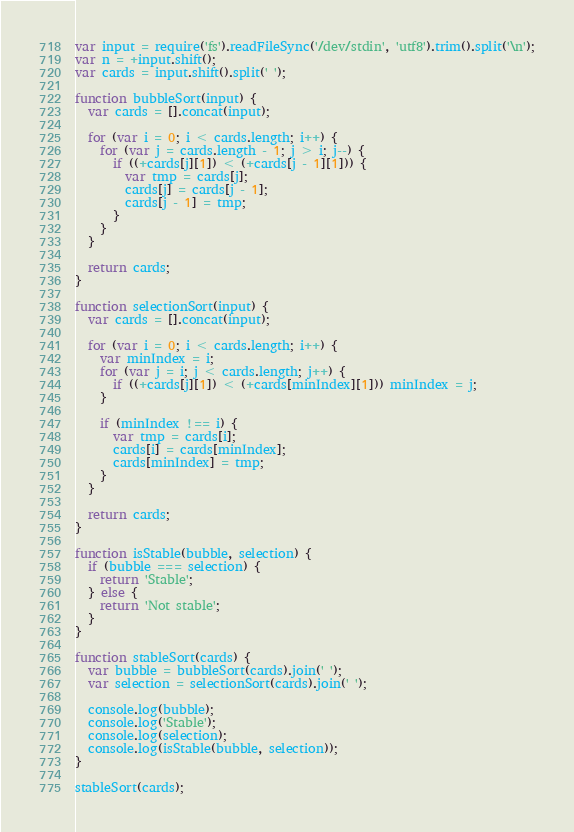<code> <loc_0><loc_0><loc_500><loc_500><_JavaScript_>var input = require('fs').readFileSync('/dev/stdin', 'utf8').trim().split('\n');
var n = +input.shift();
var cards = input.shift().split(' ');

function bubbleSort(input) {
  var cards = [].concat(input);

  for (var i = 0; i < cards.length; i++) {
    for (var j = cards.length - 1; j > i; j--) {
      if ((+cards[j][1]) < (+cards[j - 1][1])) {
        var tmp = cards[j];
        cards[j] = cards[j - 1];
        cards[j - 1] = tmp;
      }
    }
  }

  return cards;
}

function selectionSort(input) {
  var cards = [].concat(input);

  for (var i = 0; i < cards.length; i++) {
    var minIndex = i;
    for (var j = i; j < cards.length; j++) {
      if ((+cards[j][1]) < (+cards[minIndex][1])) minIndex = j;
    }

    if (minIndex !== i) {
      var tmp = cards[i];
      cards[i] = cards[minIndex];
      cards[minIndex] = tmp;
    }
  }

  return cards;
}

function isStable(bubble, selection) {
  if (bubble === selection) {
    return 'Stable';
  } else {
    return 'Not stable';
  }
}

function stableSort(cards) {
  var bubble = bubbleSort(cards).join(' ');
  var selection = selectionSort(cards).join(' ');

  console.log(bubble);
  console.log('Stable');
  console.log(selection);
  console.log(isStable(bubble, selection));
}

stableSort(cards);</code> 